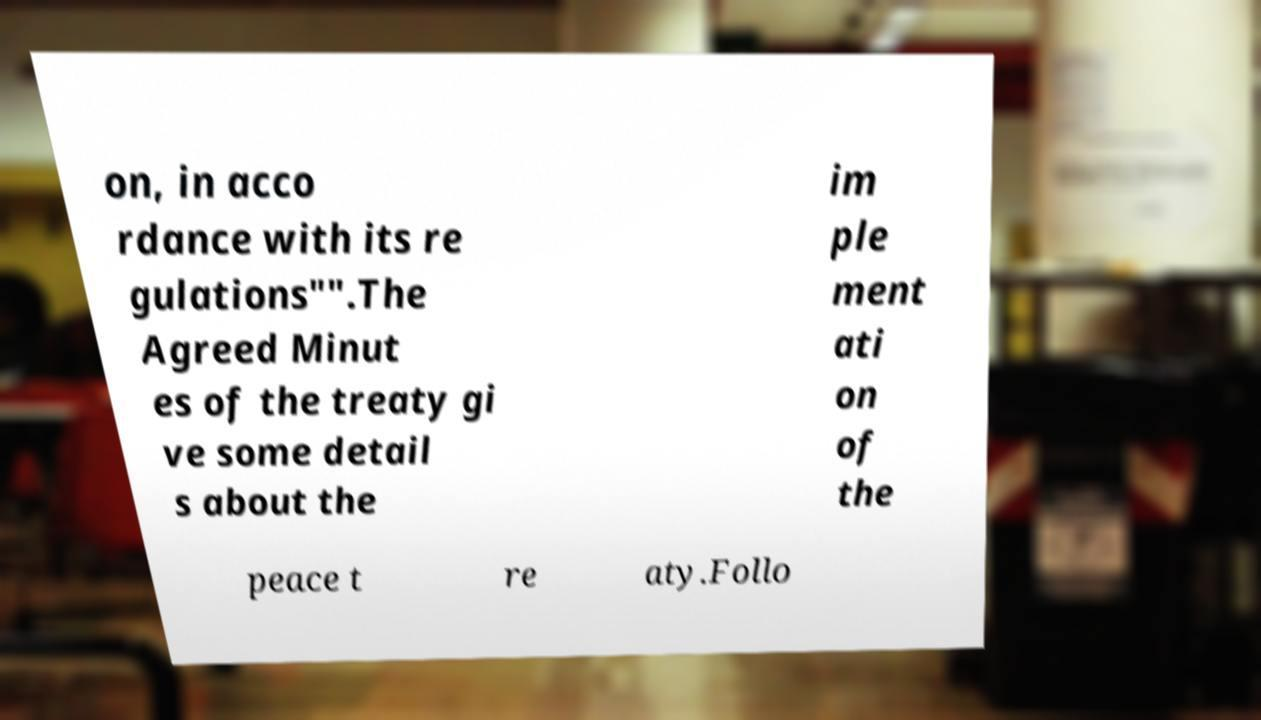Please read and relay the text visible in this image. What does it say? on, in acco rdance with its re gulations″".The Agreed Minut es of the treaty gi ve some detail s about the im ple ment ati on of the peace t re aty.Follo 